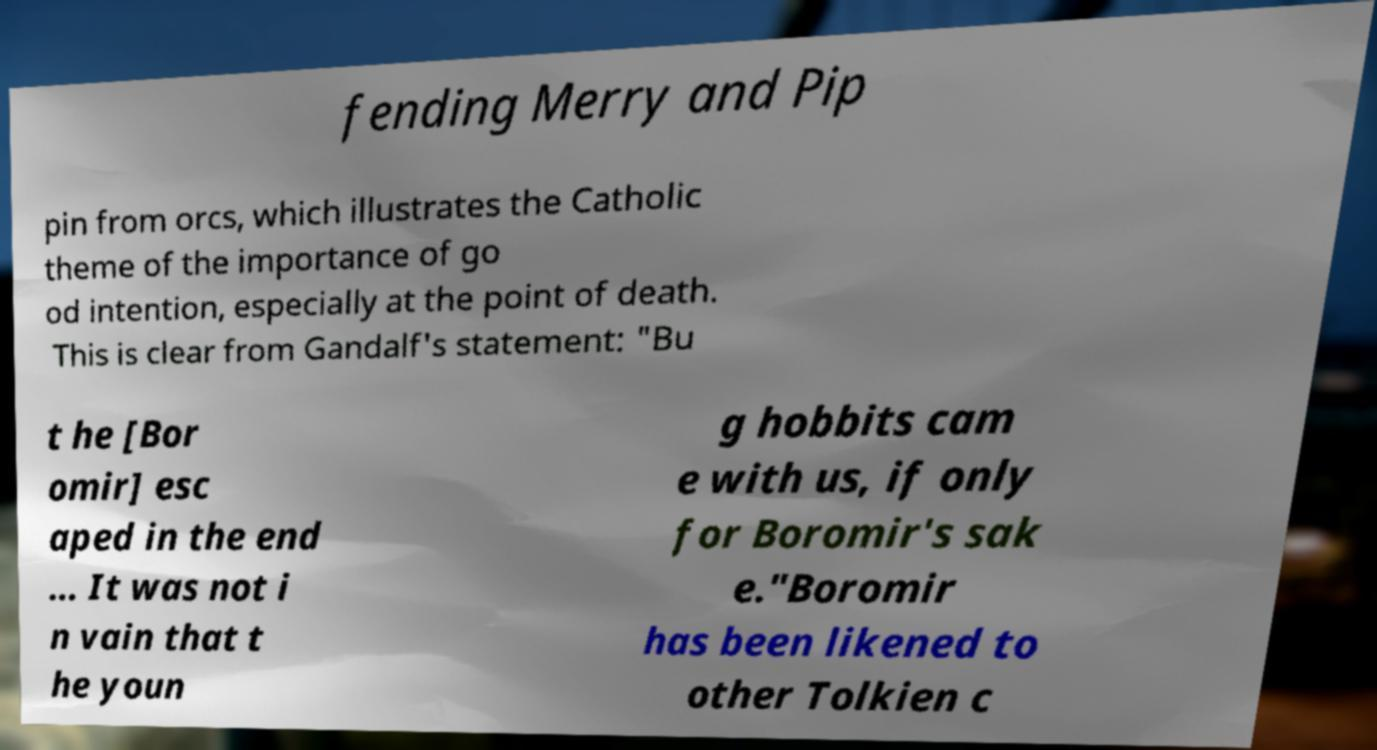Please read and relay the text visible in this image. What does it say? fending Merry and Pip pin from orcs, which illustrates the Catholic theme of the importance of go od intention, especially at the point of death. This is clear from Gandalf's statement: "Bu t he [Bor omir] esc aped in the end ... It was not i n vain that t he youn g hobbits cam e with us, if only for Boromir's sak e."Boromir has been likened to other Tolkien c 